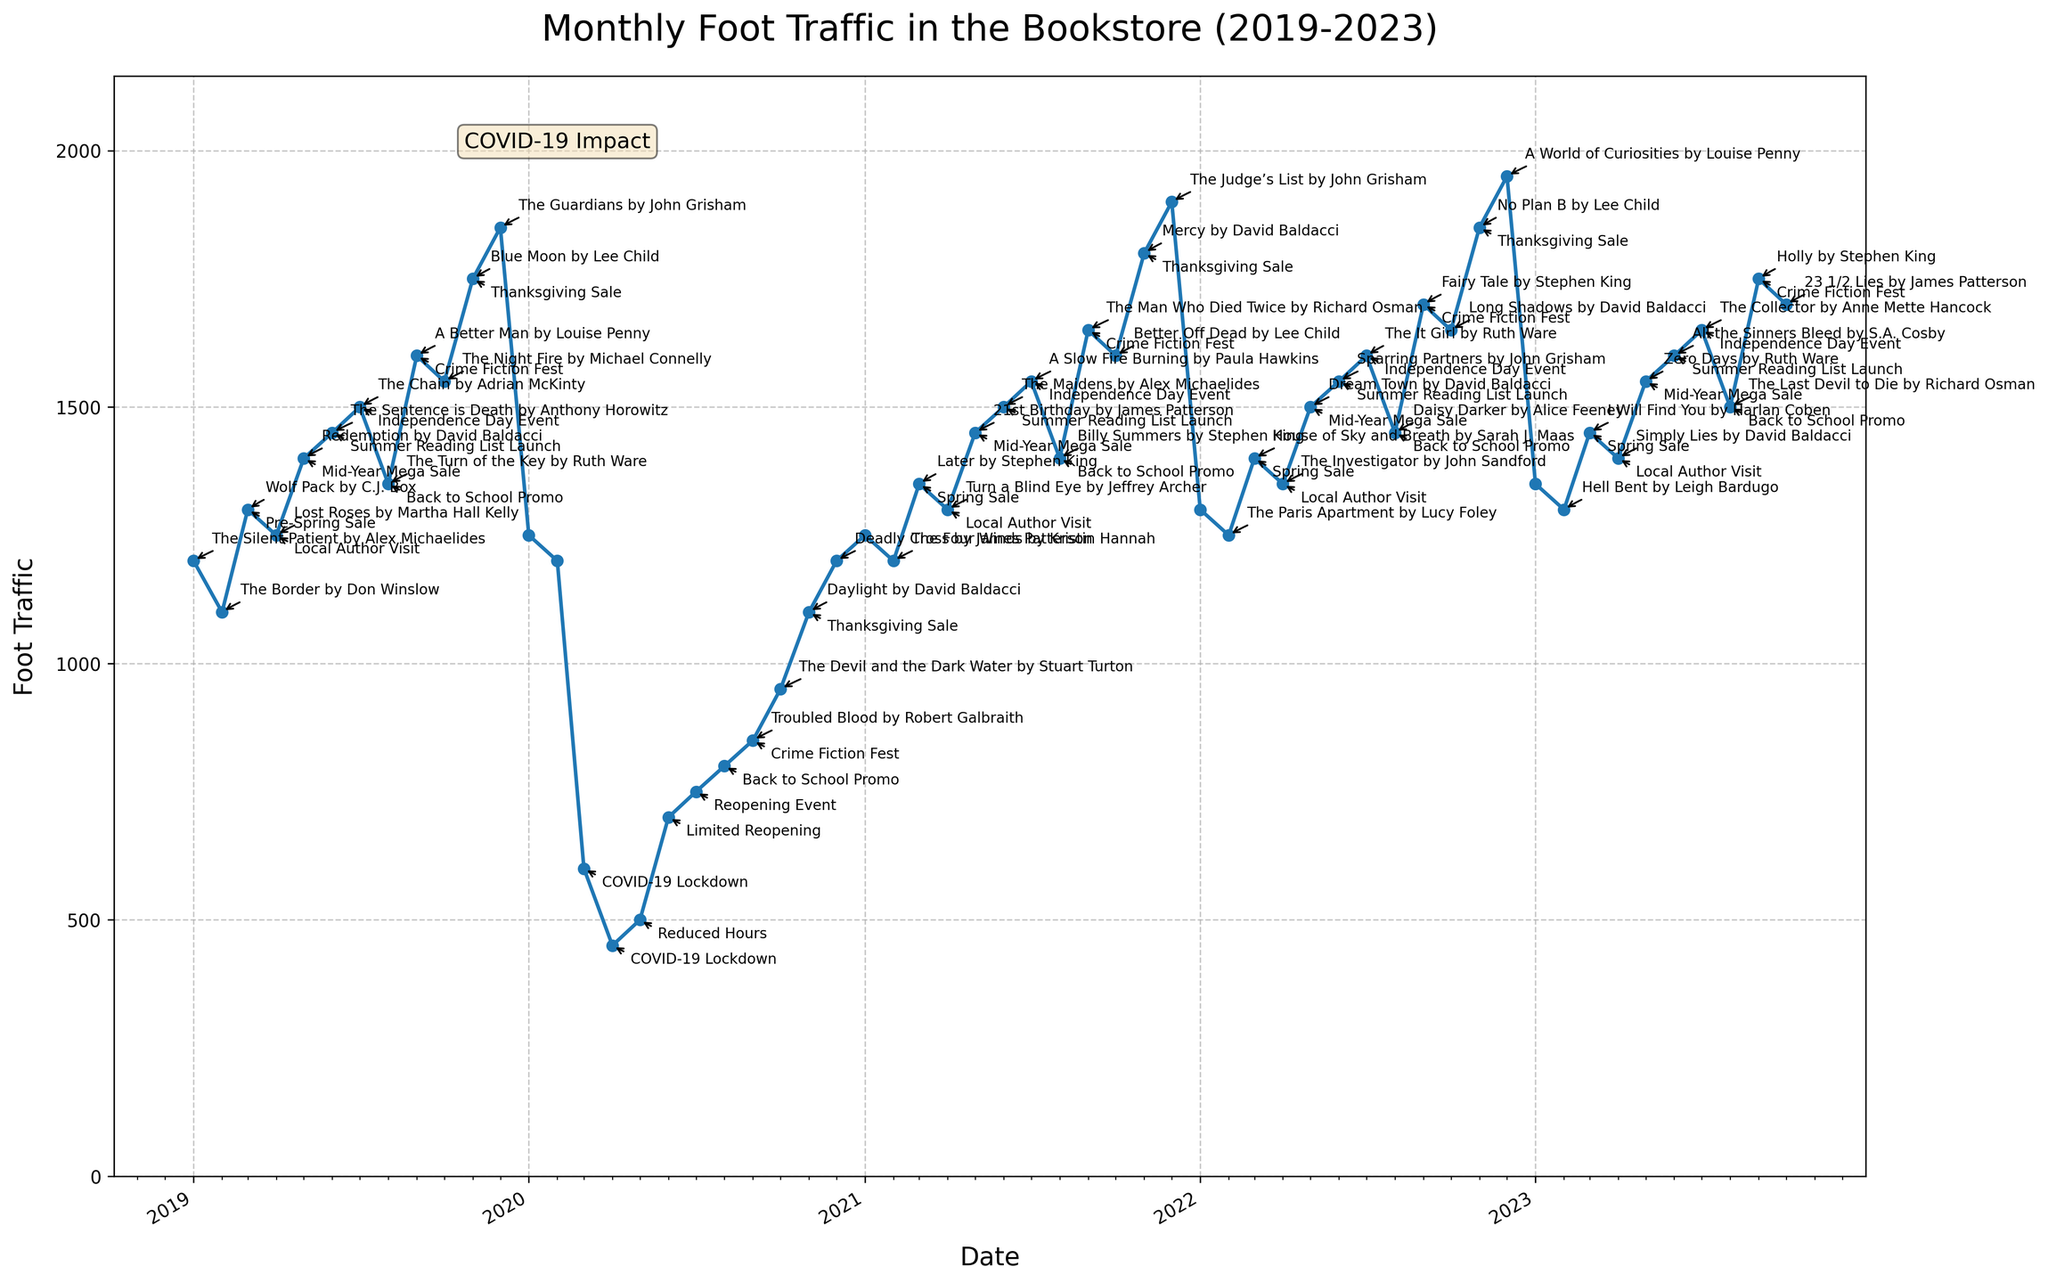What's the title of the figure? The title of the figure is displayed at the top of the plot. It reads "Monthly Foot Traffic in the Bookstore (2019-2023)".
Answer: Monthly Foot Traffic in the Bookstore (2019-2023) What is the range of the y-axis? The y-axis represents Foot Traffic, and it ranges from 0 to slightly above the highest foot traffic value shown in the plot. The highest value seems to be around 1950, so the range is from 0 to approximately 2100.
Answer: 0 to approximately 2100 How does foot traffic in December 2022 compare to December 2020? December 2022 sees a higher foot traffic value compared to December 2020. The foot traffic in December 2022 is around 1950, while in December 2020 it is around 1200.
Answer: December 2022 has higher foot traffic than December 2020 Which month and year had the lowest foot traffic and why? The lowest foot traffic is in April 2020, likely due to the COVID-19 lockdown. The foot traffic value for April 2020 is around 450, considerably lower than other periods.
Answer: April 2020 due to COVID-19 lockdown What was the foot traffic trend during the COVID-19 lockdown in 2020? Foot traffic drastically dropped in March 2020 and remained very low through April and May 2020 before gradually recovering in June and subsequent months. The trend shows a significant dip and then a slow increase.
Answer: Drastic drop in March, remained low in April and May, gradual recovery starting June What major book release is associated with the highest foot traffic in the plot? The highest foot traffic appears in December 2022 (around 1950), associated with the major book release "A World of Curiosities by Louise Penny" during the Christmas Holidays.
Answer: A World of Curiosities by Louise Penny How did the major release "The Chain by Adrian McKinty" in July 2019 affect foot traffic compared to July 2020? In July 2019, with the major release "The Chain by Adrian McKinty" and the Independence Day event, the foot traffic was around 1500. In July 2020, despite a reopening event, the foot traffic is lower, around 750, reflecting the persistence of COVID-19 impacts.
Answer: July 2019 foot traffic was higher at around 1500 compared to 750 in July 2020 What is the average foot traffic for the year 2021? To find the average foot traffic for 2021, sum the monthly foot traffic values for the year and then divide by 12. The monthly values for 2021 are: 1250, 1200, 1350, 1300, 1450, 1500, 1550, 1400, 1650, 1600, 1800, and 1900. Sum = 17950. Average = 17950 / 12 = 1495.83.
Answer: 1495.83 During which year did the foot traffic first recover to pre-COVID levels (more than or equal to 1200)? Foot traffic first recovered to pre-COVID levels (≥1200) in December 2020, where it reached 1200. The values in months prior to this were below 1200, indicating this as the recovery point.
Answer: December 2020 How did "Valentine's Day Special" events affect foot traffic across different years? Each February, foot traffic seems to slightly increase due to the "Valentine's Day Special" events, with foot traffic values of 1100 in 2019, 1200 in 2020, 1200 in 2021, 1250 in 2022, and 1300 in 2023, showing a progressive increase over the years.
Answer: Progressive increase over the years 